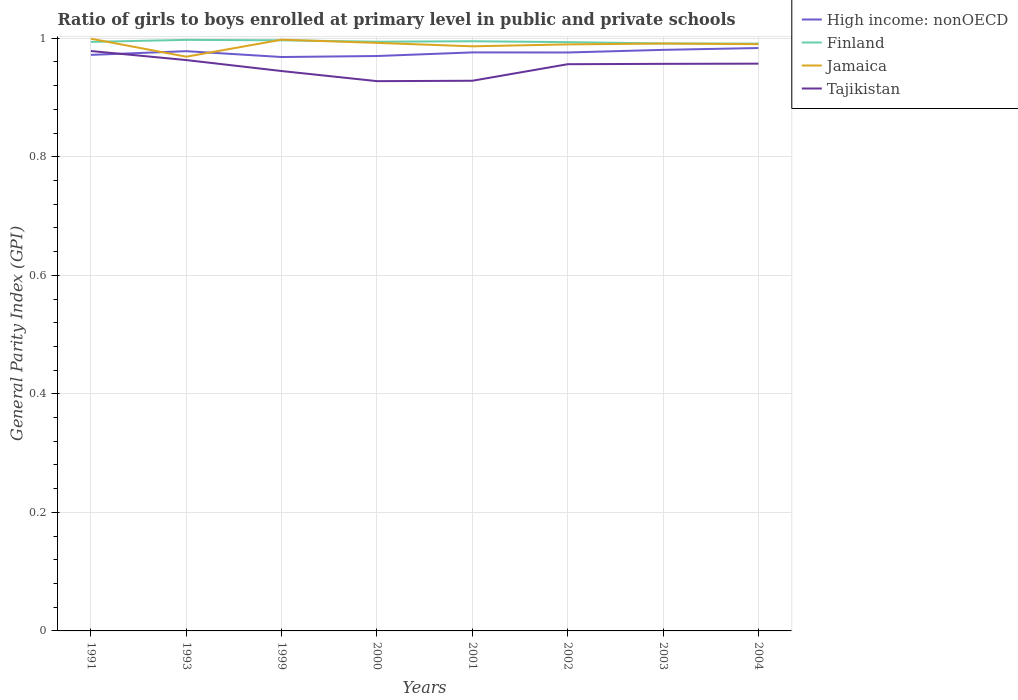Is the number of lines equal to the number of legend labels?
Provide a succinct answer. Yes. Across all years, what is the maximum general parity index in Finland?
Offer a terse response. 0.99. What is the total general parity index in Jamaica in the graph?
Offer a very short reply. 0.01. What is the difference between the highest and the second highest general parity index in Jamaica?
Your response must be concise. 0.03. How many years are there in the graph?
Offer a terse response. 8. What is the difference between two consecutive major ticks on the Y-axis?
Offer a very short reply. 0.2. Where does the legend appear in the graph?
Ensure brevity in your answer.  Top right. How many legend labels are there?
Make the answer very short. 4. What is the title of the graph?
Make the answer very short. Ratio of girls to boys enrolled at primary level in public and private schools. What is the label or title of the Y-axis?
Your answer should be very brief. General Parity Index (GPI). What is the General Parity Index (GPI) in High income: nonOECD in 1991?
Your answer should be very brief. 0.97. What is the General Parity Index (GPI) in Finland in 1991?
Make the answer very short. 0.99. What is the General Parity Index (GPI) in Jamaica in 1991?
Keep it short and to the point. 1. What is the General Parity Index (GPI) in Tajikistan in 1991?
Offer a terse response. 0.98. What is the General Parity Index (GPI) in High income: nonOECD in 1993?
Give a very brief answer. 0.98. What is the General Parity Index (GPI) in Finland in 1993?
Your answer should be compact. 1. What is the General Parity Index (GPI) of Jamaica in 1993?
Your answer should be compact. 0.97. What is the General Parity Index (GPI) in Tajikistan in 1993?
Offer a very short reply. 0.96. What is the General Parity Index (GPI) of High income: nonOECD in 1999?
Your response must be concise. 0.97. What is the General Parity Index (GPI) of Finland in 1999?
Provide a succinct answer. 1. What is the General Parity Index (GPI) in Jamaica in 1999?
Your answer should be very brief. 1. What is the General Parity Index (GPI) of Tajikistan in 1999?
Give a very brief answer. 0.94. What is the General Parity Index (GPI) in High income: nonOECD in 2000?
Ensure brevity in your answer.  0.97. What is the General Parity Index (GPI) of Finland in 2000?
Make the answer very short. 0.99. What is the General Parity Index (GPI) in Jamaica in 2000?
Offer a very short reply. 0.99. What is the General Parity Index (GPI) of Tajikistan in 2000?
Keep it short and to the point. 0.93. What is the General Parity Index (GPI) of High income: nonOECD in 2001?
Offer a very short reply. 0.98. What is the General Parity Index (GPI) in Finland in 2001?
Your answer should be compact. 0.99. What is the General Parity Index (GPI) of Jamaica in 2001?
Offer a terse response. 0.99. What is the General Parity Index (GPI) of Tajikistan in 2001?
Make the answer very short. 0.93. What is the General Parity Index (GPI) in High income: nonOECD in 2002?
Your answer should be very brief. 0.98. What is the General Parity Index (GPI) of Finland in 2002?
Provide a short and direct response. 0.99. What is the General Parity Index (GPI) of Jamaica in 2002?
Ensure brevity in your answer.  0.99. What is the General Parity Index (GPI) of Tajikistan in 2002?
Provide a succinct answer. 0.96. What is the General Parity Index (GPI) of High income: nonOECD in 2003?
Your answer should be compact. 0.98. What is the General Parity Index (GPI) in Finland in 2003?
Your answer should be very brief. 0.99. What is the General Parity Index (GPI) of Jamaica in 2003?
Make the answer very short. 0.99. What is the General Parity Index (GPI) in Tajikistan in 2003?
Offer a very short reply. 0.96. What is the General Parity Index (GPI) of High income: nonOECD in 2004?
Offer a very short reply. 0.98. What is the General Parity Index (GPI) of Finland in 2004?
Make the answer very short. 0.99. What is the General Parity Index (GPI) of Jamaica in 2004?
Give a very brief answer. 0.99. What is the General Parity Index (GPI) of Tajikistan in 2004?
Your response must be concise. 0.96. Across all years, what is the maximum General Parity Index (GPI) of High income: nonOECD?
Ensure brevity in your answer.  0.98. Across all years, what is the maximum General Parity Index (GPI) in Finland?
Offer a terse response. 1. Across all years, what is the maximum General Parity Index (GPI) of Jamaica?
Offer a terse response. 1. Across all years, what is the maximum General Parity Index (GPI) in Tajikistan?
Make the answer very short. 0.98. Across all years, what is the minimum General Parity Index (GPI) of High income: nonOECD?
Offer a very short reply. 0.97. Across all years, what is the minimum General Parity Index (GPI) of Finland?
Provide a succinct answer. 0.99. Across all years, what is the minimum General Parity Index (GPI) of Jamaica?
Give a very brief answer. 0.97. Across all years, what is the minimum General Parity Index (GPI) of Tajikistan?
Provide a succinct answer. 0.93. What is the total General Parity Index (GPI) of High income: nonOECD in the graph?
Provide a short and direct response. 7.8. What is the total General Parity Index (GPI) in Finland in the graph?
Ensure brevity in your answer.  7.95. What is the total General Parity Index (GPI) of Jamaica in the graph?
Ensure brevity in your answer.  7.91. What is the total General Parity Index (GPI) of Tajikistan in the graph?
Your response must be concise. 7.61. What is the difference between the General Parity Index (GPI) in High income: nonOECD in 1991 and that in 1993?
Ensure brevity in your answer.  -0.01. What is the difference between the General Parity Index (GPI) in Finland in 1991 and that in 1993?
Provide a succinct answer. -0. What is the difference between the General Parity Index (GPI) in Jamaica in 1991 and that in 1993?
Provide a succinct answer. 0.03. What is the difference between the General Parity Index (GPI) in Tajikistan in 1991 and that in 1993?
Ensure brevity in your answer.  0.02. What is the difference between the General Parity Index (GPI) in High income: nonOECD in 1991 and that in 1999?
Your answer should be compact. 0. What is the difference between the General Parity Index (GPI) in Finland in 1991 and that in 1999?
Your response must be concise. -0. What is the difference between the General Parity Index (GPI) of Jamaica in 1991 and that in 1999?
Keep it short and to the point. 0. What is the difference between the General Parity Index (GPI) of Tajikistan in 1991 and that in 1999?
Make the answer very short. 0.03. What is the difference between the General Parity Index (GPI) of High income: nonOECD in 1991 and that in 2000?
Make the answer very short. 0. What is the difference between the General Parity Index (GPI) of Finland in 1991 and that in 2000?
Make the answer very short. -0. What is the difference between the General Parity Index (GPI) in Jamaica in 1991 and that in 2000?
Keep it short and to the point. 0.01. What is the difference between the General Parity Index (GPI) of Tajikistan in 1991 and that in 2000?
Make the answer very short. 0.05. What is the difference between the General Parity Index (GPI) of High income: nonOECD in 1991 and that in 2001?
Provide a short and direct response. -0. What is the difference between the General Parity Index (GPI) of Finland in 1991 and that in 2001?
Give a very brief answer. -0. What is the difference between the General Parity Index (GPI) in Jamaica in 1991 and that in 2001?
Give a very brief answer. 0.01. What is the difference between the General Parity Index (GPI) in Tajikistan in 1991 and that in 2001?
Your response must be concise. 0.05. What is the difference between the General Parity Index (GPI) of High income: nonOECD in 1991 and that in 2002?
Ensure brevity in your answer.  -0. What is the difference between the General Parity Index (GPI) of Finland in 1991 and that in 2002?
Keep it short and to the point. 0. What is the difference between the General Parity Index (GPI) of Jamaica in 1991 and that in 2002?
Ensure brevity in your answer.  0.01. What is the difference between the General Parity Index (GPI) in Tajikistan in 1991 and that in 2002?
Your response must be concise. 0.02. What is the difference between the General Parity Index (GPI) in High income: nonOECD in 1991 and that in 2003?
Your response must be concise. -0.01. What is the difference between the General Parity Index (GPI) in Finland in 1991 and that in 2003?
Your response must be concise. 0. What is the difference between the General Parity Index (GPI) of Jamaica in 1991 and that in 2003?
Offer a terse response. 0.01. What is the difference between the General Parity Index (GPI) in Tajikistan in 1991 and that in 2003?
Give a very brief answer. 0.02. What is the difference between the General Parity Index (GPI) in High income: nonOECD in 1991 and that in 2004?
Provide a succinct answer. -0.01. What is the difference between the General Parity Index (GPI) in Finland in 1991 and that in 2004?
Offer a terse response. 0. What is the difference between the General Parity Index (GPI) of Jamaica in 1991 and that in 2004?
Keep it short and to the point. 0.01. What is the difference between the General Parity Index (GPI) of Tajikistan in 1991 and that in 2004?
Your answer should be very brief. 0.02. What is the difference between the General Parity Index (GPI) of High income: nonOECD in 1993 and that in 1999?
Your response must be concise. 0.01. What is the difference between the General Parity Index (GPI) in Finland in 1993 and that in 1999?
Keep it short and to the point. 0. What is the difference between the General Parity Index (GPI) of Jamaica in 1993 and that in 1999?
Give a very brief answer. -0.03. What is the difference between the General Parity Index (GPI) of Tajikistan in 1993 and that in 1999?
Ensure brevity in your answer.  0.02. What is the difference between the General Parity Index (GPI) in High income: nonOECD in 1993 and that in 2000?
Make the answer very short. 0.01. What is the difference between the General Parity Index (GPI) of Finland in 1993 and that in 2000?
Offer a terse response. 0. What is the difference between the General Parity Index (GPI) in Jamaica in 1993 and that in 2000?
Provide a succinct answer. -0.02. What is the difference between the General Parity Index (GPI) in Tajikistan in 1993 and that in 2000?
Your answer should be compact. 0.04. What is the difference between the General Parity Index (GPI) in High income: nonOECD in 1993 and that in 2001?
Provide a short and direct response. 0. What is the difference between the General Parity Index (GPI) of Finland in 1993 and that in 2001?
Make the answer very short. 0. What is the difference between the General Parity Index (GPI) in Jamaica in 1993 and that in 2001?
Your answer should be very brief. -0.02. What is the difference between the General Parity Index (GPI) of Tajikistan in 1993 and that in 2001?
Provide a succinct answer. 0.03. What is the difference between the General Parity Index (GPI) of High income: nonOECD in 1993 and that in 2002?
Your response must be concise. 0. What is the difference between the General Parity Index (GPI) in Finland in 1993 and that in 2002?
Offer a very short reply. 0. What is the difference between the General Parity Index (GPI) in Jamaica in 1993 and that in 2002?
Your answer should be very brief. -0.02. What is the difference between the General Parity Index (GPI) in Tajikistan in 1993 and that in 2002?
Keep it short and to the point. 0.01. What is the difference between the General Parity Index (GPI) of High income: nonOECD in 1993 and that in 2003?
Provide a short and direct response. -0. What is the difference between the General Parity Index (GPI) in Finland in 1993 and that in 2003?
Keep it short and to the point. 0.01. What is the difference between the General Parity Index (GPI) of Jamaica in 1993 and that in 2003?
Your answer should be very brief. -0.02. What is the difference between the General Parity Index (GPI) in Tajikistan in 1993 and that in 2003?
Your answer should be very brief. 0.01. What is the difference between the General Parity Index (GPI) in High income: nonOECD in 1993 and that in 2004?
Give a very brief answer. -0.01. What is the difference between the General Parity Index (GPI) of Finland in 1993 and that in 2004?
Offer a terse response. 0.01. What is the difference between the General Parity Index (GPI) of Jamaica in 1993 and that in 2004?
Make the answer very short. -0.02. What is the difference between the General Parity Index (GPI) in Tajikistan in 1993 and that in 2004?
Give a very brief answer. 0.01. What is the difference between the General Parity Index (GPI) in High income: nonOECD in 1999 and that in 2000?
Give a very brief answer. -0. What is the difference between the General Parity Index (GPI) in Finland in 1999 and that in 2000?
Provide a succinct answer. 0. What is the difference between the General Parity Index (GPI) in Jamaica in 1999 and that in 2000?
Offer a terse response. 0.01. What is the difference between the General Parity Index (GPI) in Tajikistan in 1999 and that in 2000?
Your answer should be very brief. 0.02. What is the difference between the General Parity Index (GPI) of High income: nonOECD in 1999 and that in 2001?
Keep it short and to the point. -0.01. What is the difference between the General Parity Index (GPI) in Finland in 1999 and that in 2001?
Ensure brevity in your answer.  0. What is the difference between the General Parity Index (GPI) of Jamaica in 1999 and that in 2001?
Keep it short and to the point. 0.01. What is the difference between the General Parity Index (GPI) of Tajikistan in 1999 and that in 2001?
Your response must be concise. 0.02. What is the difference between the General Parity Index (GPI) in High income: nonOECD in 1999 and that in 2002?
Provide a short and direct response. -0.01. What is the difference between the General Parity Index (GPI) of Finland in 1999 and that in 2002?
Ensure brevity in your answer.  0. What is the difference between the General Parity Index (GPI) of Jamaica in 1999 and that in 2002?
Your response must be concise. 0.01. What is the difference between the General Parity Index (GPI) in Tajikistan in 1999 and that in 2002?
Offer a very short reply. -0.01. What is the difference between the General Parity Index (GPI) in High income: nonOECD in 1999 and that in 2003?
Your response must be concise. -0.01. What is the difference between the General Parity Index (GPI) of Finland in 1999 and that in 2003?
Provide a short and direct response. 0.01. What is the difference between the General Parity Index (GPI) of Jamaica in 1999 and that in 2003?
Keep it short and to the point. 0.01. What is the difference between the General Parity Index (GPI) of Tajikistan in 1999 and that in 2003?
Ensure brevity in your answer.  -0.01. What is the difference between the General Parity Index (GPI) of High income: nonOECD in 1999 and that in 2004?
Your answer should be compact. -0.02. What is the difference between the General Parity Index (GPI) of Finland in 1999 and that in 2004?
Offer a terse response. 0.01. What is the difference between the General Parity Index (GPI) of Jamaica in 1999 and that in 2004?
Offer a terse response. 0.01. What is the difference between the General Parity Index (GPI) of Tajikistan in 1999 and that in 2004?
Offer a terse response. -0.01. What is the difference between the General Parity Index (GPI) in High income: nonOECD in 2000 and that in 2001?
Give a very brief answer. -0.01. What is the difference between the General Parity Index (GPI) in Finland in 2000 and that in 2001?
Offer a very short reply. -0. What is the difference between the General Parity Index (GPI) of Jamaica in 2000 and that in 2001?
Keep it short and to the point. 0.01. What is the difference between the General Parity Index (GPI) of Tajikistan in 2000 and that in 2001?
Offer a terse response. -0. What is the difference between the General Parity Index (GPI) of High income: nonOECD in 2000 and that in 2002?
Provide a short and direct response. -0.01. What is the difference between the General Parity Index (GPI) of Finland in 2000 and that in 2002?
Offer a terse response. 0. What is the difference between the General Parity Index (GPI) in Jamaica in 2000 and that in 2002?
Your answer should be very brief. 0. What is the difference between the General Parity Index (GPI) of Tajikistan in 2000 and that in 2002?
Ensure brevity in your answer.  -0.03. What is the difference between the General Parity Index (GPI) in High income: nonOECD in 2000 and that in 2003?
Keep it short and to the point. -0.01. What is the difference between the General Parity Index (GPI) of Finland in 2000 and that in 2003?
Make the answer very short. 0. What is the difference between the General Parity Index (GPI) of Jamaica in 2000 and that in 2003?
Provide a succinct answer. 0. What is the difference between the General Parity Index (GPI) of Tajikistan in 2000 and that in 2003?
Keep it short and to the point. -0.03. What is the difference between the General Parity Index (GPI) of High income: nonOECD in 2000 and that in 2004?
Keep it short and to the point. -0.01. What is the difference between the General Parity Index (GPI) in Finland in 2000 and that in 2004?
Your answer should be compact. 0. What is the difference between the General Parity Index (GPI) in Jamaica in 2000 and that in 2004?
Keep it short and to the point. 0. What is the difference between the General Parity Index (GPI) of Tajikistan in 2000 and that in 2004?
Make the answer very short. -0.03. What is the difference between the General Parity Index (GPI) in Finland in 2001 and that in 2002?
Your answer should be very brief. 0. What is the difference between the General Parity Index (GPI) of Jamaica in 2001 and that in 2002?
Offer a very short reply. -0. What is the difference between the General Parity Index (GPI) of Tajikistan in 2001 and that in 2002?
Make the answer very short. -0.03. What is the difference between the General Parity Index (GPI) of High income: nonOECD in 2001 and that in 2003?
Your answer should be very brief. -0. What is the difference between the General Parity Index (GPI) of Finland in 2001 and that in 2003?
Ensure brevity in your answer.  0. What is the difference between the General Parity Index (GPI) of Jamaica in 2001 and that in 2003?
Keep it short and to the point. -0. What is the difference between the General Parity Index (GPI) of Tajikistan in 2001 and that in 2003?
Provide a short and direct response. -0.03. What is the difference between the General Parity Index (GPI) of High income: nonOECD in 2001 and that in 2004?
Your answer should be very brief. -0.01. What is the difference between the General Parity Index (GPI) of Finland in 2001 and that in 2004?
Ensure brevity in your answer.  0. What is the difference between the General Parity Index (GPI) of Jamaica in 2001 and that in 2004?
Your response must be concise. -0. What is the difference between the General Parity Index (GPI) in Tajikistan in 2001 and that in 2004?
Offer a terse response. -0.03. What is the difference between the General Parity Index (GPI) in High income: nonOECD in 2002 and that in 2003?
Provide a short and direct response. -0. What is the difference between the General Parity Index (GPI) of Finland in 2002 and that in 2003?
Offer a terse response. 0. What is the difference between the General Parity Index (GPI) of Jamaica in 2002 and that in 2003?
Your answer should be very brief. -0. What is the difference between the General Parity Index (GPI) in Tajikistan in 2002 and that in 2003?
Make the answer very short. -0. What is the difference between the General Parity Index (GPI) in High income: nonOECD in 2002 and that in 2004?
Your answer should be compact. -0.01. What is the difference between the General Parity Index (GPI) in Finland in 2002 and that in 2004?
Your response must be concise. 0. What is the difference between the General Parity Index (GPI) in Jamaica in 2002 and that in 2004?
Give a very brief answer. -0. What is the difference between the General Parity Index (GPI) of Tajikistan in 2002 and that in 2004?
Offer a terse response. -0. What is the difference between the General Parity Index (GPI) in High income: nonOECD in 2003 and that in 2004?
Keep it short and to the point. -0. What is the difference between the General Parity Index (GPI) in Finland in 2003 and that in 2004?
Provide a succinct answer. 0. What is the difference between the General Parity Index (GPI) in Jamaica in 2003 and that in 2004?
Your answer should be compact. 0. What is the difference between the General Parity Index (GPI) in Tajikistan in 2003 and that in 2004?
Your answer should be compact. -0. What is the difference between the General Parity Index (GPI) of High income: nonOECD in 1991 and the General Parity Index (GPI) of Finland in 1993?
Make the answer very short. -0.03. What is the difference between the General Parity Index (GPI) of High income: nonOECD in 1991 and the General Parity Index (GPI) of Jamaica in 1993?
Your answer should be compact. 0. What is the difference between the General Parity Index (GPI) in High income: nonOECD in 1991 and the General Parity Index (GPI) in Tajikistan in 1993?
Ensure brevity in your answer.  0.01. What is the difference between the General Parity Index (GPI) of Finland in 1991 and the General Parity Index (GPI) of Jamaica in 1993?
Provide a succinct answer. 0.03. What is the difference between the General Parity Index (GPI) in Finland in 1991 and the General Parity Index (GPI) in Tajikistan in 1993?
Your answer should be compact. 0.03. What is the difference between the General Parity Index (GPI) in Jamaica in 1991 and the General Parity Index (GPI) in Tajikistan in 1993?
Offer a very short reply. 0.04. What is the difference between the General Parity Index (GPI) of High income: nonOECD in 1991 and the General Parity Index (GPI) of Finland in 1999?
Your answer should be compact. -0.02. What is the difference between the General Parity Index (GPI) of High income: nonOECD in 1991 and the General Parity Index (GPI) of Jamaica in 1999?
Your answer should be very brief. -0.03. What is the difference between the General Parity Index (GPI) of High income: nonOECD in 1991 and the General Parity Index (GPI) of Tajikistan in 1999?
Offer a very short reply. 0.03. What is the difference between the General Parity Index (GPI) in Finland in 1991 and the General Parity Index (GPI) in Jamaica in 1999?
Your response must be concise. -0. What is the difference between the General Parity Index (GPI) in Finland in 1991 and the General Parity Index (GPI) in Tajikistan in 1999?
Your response must be concise. 0.05. What is the difference between the General Parity Index (GPI) in Jamaica in 1991 and the General Parity Index (GPI) in Tajikistan in 1999?
Provide a succinct answer. 0.05. What is the difference between the General Parity Index (GPI) in High income: nonOECD in 1991 and the General Parity Index (GPI) in Finland in 2000?
Make the answer very short. -0.02. What is the difference between the General Parity Index (GPI) of High income: nonOECD in 1991 and the General Parity Index (GPI) of Jamaica in 2000?
Offer a terse response. -0.02. What is the difference between the General Parity Index (GPI) of High income: nonOECD in 1991 and the General Parity Index (GPI) of Tajikistan in 2000?
Offer a very short reply. 0.04. What is the difference between the General Parity Index (GPI) of Finland in 1991 and the General Parity Index (GPI) of Jamaica in 2000?
Your response must be concise. 0. What is the difference between the General Parity Index (GPI) in Finland in 1991 and the General Parity Index (GPI) in Tajikistan in 2000?
Keep it short and to the point. 0.07. What is the difference between the General Parity Index (GPI) of Jamaica in 1991 and the General Parity Index (GPI) of Tajikistan in 2000?
Give a very brief answer. 0.07. What is the difference between the General Parity Index (GPI) of High income: nonOECD in 1991 and the General Parity Index (GPI) of Finland in 2001?
Offer a terse response. -0.02. What is the difference between the General Parity Index (GPI) in High income: nonOECD in 1991 and the General Parity Index (GPI) in Jamaica in 2001?
Give a very brief answer. -0.01. What is the difference between the General Parity Index (GPI) in High income: nonOECD in 1991 and the General Parity Index (GPI) in Tajikistan in 2001?
Offer a terse response. 0.04. What is the difference between the General Parity Index (GPI) of Finland in 1991 and the General Parity Index (GPI) of Jamaica in 2001?
Provide a short and direct response. 0.01. What is the difference between the General Parity Index (GPI) in Finland in 1991 and the General Parity Index (GPI) in Tajikistan in 2001?
Offer a very short reply. 0.07. What is the difference between the General Parity Index (GPI) in Jamaica in 1991 and the General Parity Index (GPI) in Tajikistan in 2001?
Offer a terse response. 0.07. What is the difference between the General Parity Index (GPI) of High income: nonOECD in 1991 and the General Parity Index (GPI) of Finland in 2002?
Keep it short and to the point. -0.02. What is the difference between the General Parity Index (GPI) of High income: nonOECD in 1991 and the General Parity Index (GPI) of Jamaica in 2002?
Your answer should be very brief. -0.02. What is the difference between the General Parity Index (GPI) of High income: nonOECD in 1991 and the General Parity Index (GPI) of Tajikistan in 2002?
Make the answer very short. 0.02. What is the difference between the General Parity Index (GPI) of Finland in 1991 and the General Parity Index (GPI) of Jamaica in 2002?
Your answer should be compact. 0. What is the difference between the General Parity Index (GPI) in Finland in 1991 and the General Parity Index (GPI) in Tajikistan in 2002?
Provide a short and direct response. 0.04. What is the difference between the General Parity Index (GPI) of Jamaica in 1991 and the General Parity Index (GPI) of Tajikistan in 2002?
Provide a short and direct response. 0.04. What is the difference between the General Parity Index (GPI) of High income: nonOECD in 1991 and the General Parity Index (GPI) of Finland in 2003?
Give a very brief answer. -0.02. What is the difference between the General Parity Index (GPI) of High income: nonOECD in 1991 and the General Parity Index (GPI) of Jamaica in 2003?
Ensure brevity in your answer.  -0.02. What is the difference between the General Parity Index (GPI) of High income: nonOECD in 1991 and the General Parity Index (GPI) of Tajikistan in 2003?
Your answer should be compact. 0.02. What is the difference between the General Parity Index (GPI) of Finland in 1991 and the General Parity Index (GPI) of Jamaica in 2003?
Your answer should be very brief. 0. What is the difference between the General Parity Index (GPI) of Finland in 1991 and the General Parity Index (GPI) of Tajikistan in 2003?
Give a very brief answer. 0.04. What is the difference between the General Parity Index (GPI) in Jamaica in 1991 and the General Parity Index (GPI) in Tajikistan in 2003?
Your answer should be compact. 0.04. What is the difference between the General Parity Index (GPI) in High income: nonOECD in 1991 and the General Parity Index (GPI) in Finland in 2004?
Make the answer very short. -0.02. What is the difference between the General Parity Index (GPI) of High income: nonOECD in 1991 and the General Parity Index (GPI) of Jamaica in 2004?
Keep it short and to the point. -0.02. What is the difference between the General Parity Index (GPI) of High income: nonOECD in 1991 and the General Parity Index (GPI) of Tajikistan in 2004?
Ensure brevity in your answer.  0.01. What is the difference between the General Parity Index (GPI) in Finland in 1991 and the General Parity Index (GPI) in Jamaica in 2004?
Ensure brevity in your answer.  0. What is the difference between the General Parity Index (GPI) of Finland in 1991 and the General Parity Index (GPI) of Tajikistan in 2004?
Make the answer very short. 0.04. What is the difference between the General Parity Index (GPI) of Jamaica in 1991 and the General Parity Index (GPI) of Tajikistan in 2004?
Your answer should be compact. 0.04. What is the difference between the General Parity Index (GPI) of High income: nonOECD in 1993 and the General Parity Index (GPI) of Finland in 1999?
Provide a succinct answer. -0.02. What is the difference between the General Parity Index (GPI) of High income: nonOECD in 1993 and the General Parity Index (GPI) of Jamaica in 1999?
Your answer should be very brief. -0.02. What is the difference between the General Parity Index (GPI) in High income: nonOECD in 1993 and the General Parity Index (GPI) in Tajikistan in 1999?
Provide a short and direct response. 0.03. What is the difference between the General Parity Index (GPI) of Finland in 1993 and the General Parity Index (GPI) of Jamaica in 1999?
Provide a short and direct response. -0. What is the difference between the General Parity Index (GPI) in Finland in 1993 and the General Parity Index (GPI) in Tajikistan in 1999?
Offer a terse response. 0.05. What is the difference between the General Parity Index (GPI) in Jamaica in 1993 and the General Parity Index (GPI) in Tajikistan in 1999?
Provide a short and direct response. 0.02. What is the difference between the General Parity Index (GPI) in High income: nonOECD in 1993 and the General Parity Index (GPI) in Finland in 2000?
Provide a succinct answer. -0.02. What is the difference between the General Parity Index (GPI) in High income: nonOECD in 1993 and the General Parity Index (GPI) in Jamaica in 2000?
Provide a short and direct response. -0.01. What is the difference between the General Parity Index (GPI) of High income: nonOECD in 1993 and the General Parity Index (GPI) of Tajikistan in 2000?
Your answer should be compact. 0.05. What is the difference between the General Parity Index (GPI) of Finland in 1993 and the General Parity Index (GPI) of Jamaica in 2000?
Provide a short and direct response. 0.01. What is the difference between the General Parity Index (GPI) of Finland in 1993 and the General Parity Index (GPI) of Tajikistan in 2000?
Give a very brief answer. 0.07. What is the difference between the General Parity Index (GPI) of Jamaica in 1993 and the General Parity Index (GPI) of Tajikistan in 2000?
Offer a terse response. 0.04. What is the difference between the General Parity Index (GPI) of High income: nonOECD in 1993 and the General Parity Index (GPI) of Finland in 2001?
Provide a short and direct response. -0.02. What is the difference between the General Parity Index (GPI) in High income: nonOECD in 1993 and the General Parity Index (GPI) in Jamaica in 2001?
Offer a terse response. -0.01. What is the difference between the General Parity Index (GPI) in High income: nonOECD in 1993 and the General Parity Index (GPI) in Tajikistan in 2001?
Offer a terse response. 0.05. What is the difference between the General Parity Index (GPI) in Finland in 1993 and the General Parity Index (GPI) in Jamaica in 2001?
Keep it short and to the point. 0.01. What is the difference between the General Parity Index (GPI) of Finland in 1993 and the General Parity Index (GPI) of Tajikistan in 2001?
Provide a short and direct response. 0.07. What is the difference between the General Parity Index (GPI) in Jamaica in 1993 and the General Parity Index (GPI) in Tajikistan in 2001?
Provide a succinct answer. 0.04. What is the difference between the General Parity Index (GPI) in High income: nonOECD in 1993 and the General Parity Index (GPI) in Finland in 2002?
Make the answer very short. -0.02. What is the difference between the General Parity Index (GPI) in High income: nonOECD in 1993 and the General Parity Index (GPI) in Jamaica in 2002?
Keep it short and to the point. -0.01. What is the difference between the General Parity Index (GPI) of High income: nonOECD in 1993 and the General Parity Index (GPI) of Tajikistan in 2002?
Offer a very short reply. 0.02. What is the difference between the General Parity Index (GPI) of Finland in 1993 and the General Parity Index (GPI) of Jamaica in 2002?
Make the answer very short. 0.01. What is the difference between the General Parity Index (GPI) in Finland in 1993 and the General Parity Index (GPI) in Tajikistan in 2002?
Give a very brief answer. 0.04. What is the difference between the General Parity Index (GPI) in Jamaica in 1993 and the General Parity Index (GPI) in Tajikistan in 2002?
Your response must be concise. 0.01. What is the difference between the General Parity Index (GPI) of High income: nonOECD in 1993 and the General Parity Index (GPI) of Finland in 2003?
Ensure brevity in your answer.  -0.01. What is the difference between the General Parity Index (GPI) of High income: nonOECD in 1993 and the General Parity Index (GPI) of Jamaica in 2003?
Make the answer very short. -0.01. What is the difference between the General Parity Index (GPI) in High income: nonOECD in 1993 and the General Parity Index (GPI) in Tajikistan in 2003?
Ensure brevity in your answer.  0.02. What is the difference between the General Parity Index (GPI) in Finland in 1993 and the General Parity Index (GPI) in Jamaica in 2003?
Your response must be concise. 0.01. What is the difference between the General Parity Index (GPI) in Finland in 1993 and the General Parity Index (GPI) in Tajikistan in 2003?
Your answer should be very brief. 0.04. What is the difference between the General Parity Index (GPI) of Jamaica in 1993 and the General Parity Index (GPI) of Tajikistan in 2003?
Provide a succinct answer. 0.01. What is the difference between the General Parity Index (GPI) of High income: nonOECD in 1993 and the General Parity Index (GPI) of Finland in 2004?
Your answer should be compact. -0.01. What is the difference between the General Parity Index (GPI) of High income: nonOECD in 1993 and the General Parity Index (GPI) of Jamaica in 2004?
Give a very brief answer. -0.01. What is the difference between the General Parity Index (GPI) in High income: nonOECD in 1993 and the General Parity Index (GPI) in Tajikistan in 2004?
Make the answer very short. 0.02. What is the difference between the General Parity Index (GPI) in Finland in 1993 and the General Parity Index (GPI) in Jamaica in 2004?
Your answer should be very brief. 0.01. What is the difference between the General Parity Index (GPI) in Finland in 1993 and the General Parity Index (GPI) in Tajikistan in 2004?
Your answer should be compact. 0.04. What is the difference between the General Parity Index (GPI) of Jamaica in 1993 and the General Parity Index (GPI) of Tajikistan in 2004?
Offer a very short reply. 0.01. What is the difference between the General Parity Index (GPI) of High income: nonOECD in 1999 and the General Parity Index (GPI) of Finland in 2000?
Ensure brevity in your answer.  -0.03. What is the difference between the General Parity Index (GPI) of High income: nonOECD in 1999 and the General Parity Index (GPI) of Jamaica in 2000?
Your response must be concise. -0.02. What is the difference between the General Parity Index (GPI) of High income: nonOECD in 1999 and the General Parity Index (GPI) of Tajikistan in 2000?
Your response must be concise. 0.04. What is the difference between the General Parity Index (GPI) of Finland in 1999 and the General Parity Index (GPI) of Jamaica in 2000?
Keep it short and to the point. 0. What is the difference between the General Parity Index (GPI) of Finland in 1999 and the General Parity Index (GPI) of Tajikistan in 2000?
Keep it short and to the point. 0.07. What is the difference between the General Parity Index (GPI) in Jamaica in 1999 and the General Parity Index (GPI) in Tajikistan in 2000?
Your response must be concise. 0.07. What is the difference between the General Parity Index (GPI) in High income: nonOECD in 1999 and the General Parity Index (GPI) in Finland in 2001?
Offer a very short reply. -0.03. What is the difference between the General Parity Index (GPI) of High income: nonOECD in 1999 and the General Parity Index (GPI) of Jamaica in 2001?
Your answer should be compact. -0.02. What is the difference between the General Parity Index (GPI) in High income: nonOECD in 1999 and the General Parity Index (GPI) in Tajikistan in 2001?
Offer a very short reply. 0.04. What is the difference between the General Parity Index (GPI) in Finland in 1999 and the General Parity Index (GPI) in Jamaica in 2001?
Your answer should be compact. 0.01. What is the difference between the General Parity Index (GPI) of Finland in 1999 and the General Parity Index (GPI) of Tajikistan in 2001?
Provide a short and direct response. 0.07. What is the difference between the General Parity Index (GPI) of Jamaica in 1999 and the General Parity Index (GPI) of Tajikistan in 2001?
Offer a very short reply. 0.07. What is the difference between the General Parity Index (GPI) of High income: nonOECD in 1999 and the General Parity Index (GPI) of Finland in 2002?
Your response must be concise. -0.03. What is the difference between the General Parity Index (GPI) of High income: nonOECD in 1999 and the General Parity Index (GPI) of Jamaica in 2002?
Keep it short and to the point. -0.02. What is the difference between the General Parity Index (GPI) of High income: nonOECD in 1999 and the General Parity Index (GPI) of Tajikistan in 2002?
Offer a terse response. 0.01. What is the difference between the General Parity Index (GPI) in Finland in 1999 and the General Parity Index (GPI) in Jamaica in 2002?
Give a very brief answer. 0.01. What is the difference between the General Parity Index (GPI) of Finland in 1999 and the General Parity Index (GPI) of Tajikistan in 2002?
Offer a very short reply. 0.04. What is the difference between the General Parity Index (GPI) of Jamaica in 1999 and the General Parity Index (GPI) of Tajikistan in 2002?
Ensure brevity in your answer.  0.04. What is the difference between the General Parity Index (GPI) in High income: nonOECD in 1999 and the General Parity Index (GPI) in Finland in 2003?
Your response must be concise. -0.02. What is the difference between the General Parity Index (GPI) in High income: nonOECD in 1999 and the General Parity Index (GPI) in Jamaica in 2003?
Your answer should be very brief. -0.02. What is the difference between the General Parity Index (GPI) of High income: nonOECD in 1999 and the General Parity Index (GPI) of Tajikistan in 2003?
Ensure brevity in your answer.  0.01. What is the difference between the General Parity Index (GPI) of Finland in 1999 and the General Parity Index (GPI) of Jamaica in 2003?
Give a very brief answer. 0.01. What is the difference between the General Parity Index (GPI) of Finland in 1999 and the General Parity Index (GPI) of Tajikistan in 2003?
Offer a very short reply. 0.04. What is the difference between the General Parity Index (GPI) of Jamaica in 1999 and the General Parity Index (GPI) of Tajikistan in 2003?
Offer a very short reply. 0.04. What is the difference between the General Parity Index (GPI) of High income: nonOECD in 1999 and the General Parity Index (GPI) of Finland in 2004?
Provide a short and direct response. -0.02. What is the difference between the General Parity Index (GPI) of High income: nonOECD in 1999 and the General Parity Index (GPI) of Jamaica in 2004?
Ensure brevity in your answer.  -0.02. What is the difference between the General Parity Index (GPI) of High income: nonOECD in 1999 and the General Parity Index (GPI) of Tajikistan in 2004?
Provide a succinct answer. 0.01. What is the difference between the General Parity Index (GPI) in Finland in 1999 and the General Parity Index (GPI) in Jamaica in 2004?
Ensure brevity in your answer.  0.01. What is the difference between the General Parity Index (GPI) of Finland in 1999 and the General Parity Index (GPI) of Tajikistan in 2004?
Ensure brevity in your answer.  0.04. What is the difference between the General Parity Index (GPI) of Jamaica in 1999 and the General Parity Index (GPI) of Tajikistan in 2004?
Offer a terse response. 0.04. What is the difference between the General Parity Index (GPI) in High income: nonOECD in 2000 and the General Parity Index (GPI) in Finland in 2001?
Provide a succinct answer. -0.02. What is the difference between the General Parity Index (GPI) in High income: nonOECD in 2000 and the General Parity Index (GPI) in Jamaica in 2001?
Ensure brevity in your answer.  -0.02. What is the difference between the General Parity Index (GPI) of High income: nonOECD in 2000 and the General Parity Index (GPI) of Tajikistan in 2001?
Give a very brief answer. 0.04. What is the difference between the General Parity Index (GPI) in Finland in 2000 and the General Parity Index (GPI) in Jamaica in 2001?
Provide a succinct answer. 0.01. What is the difference between the General Parity Index (GPI) in Finland in 2000 and the General Parity Index (GPI) in Tajikistan in 2001?
Your answer should be compact. 0.07. What is the difference between the General Parity Index (GPI) in Jamaica in 2000 and the General Parity Index (GPI) in Tajikistan in 2001?
Make the answer very short. 0.06. What is the difference between the General Parity Index (GPI) in High income: nonOECD in 2000 and the General Parity Index (GPI) in Finland in 2002?
Give a very brief answer. -0.02. What is the difference between the General Parity Index (GPI) of High income: nonOECD in 2000 and the General Parity Index (GPI) of Jamaica in 2002?
Make the answer very short. -0.02. What is the difference between the General Parity Index (GPI) of High income: nonOECD in 2000 and the General Parity Index (GPI) of Tajikistan in 2002?
Your answer should be compact. 0.01. What is the difference between the General Parity Index (GPI) in Finland in 2000 and the General Parity Index (GPI) in Jamaica in 2002?
Provide a succinct answer. 0. What is the difference between the General Parity Index (GPI) of Finland in 2000 and the General Parity Index (GPI) of Tajikistan in 2002?
Keep it short and to the point. 0.04. What is the difference between the General Parity Index (GPI) of Jamaica in 2000 and the General Parity Index (GPI) of Tajikistan in 2002?
Keep it short and to the point. 0.04. What is the difference between the General Parity Index (GPI) of High income: nonOECD in 2000 and the General Parity Index (GPI) of Finland in 2003?
Keep it short and to the point. -0.02. What is the difference between the General Parity Index (GPI) in High income: nonOECD in 2000 and the General Parity Index (GPI) in Jamaica in 2003?
Provide a short and direct response. -0.02. What is the difference between the General Parity Index (GPI) in High income: nonOECD in 2000 and the General Parity Index (GPI) in Tajikistan in 2003?
Your answer should be compact. 0.01. What is the difference between the General Parity Index (GPI) of Finland in 2000 and the General Parity Index (GPI) of Jamaica in 2003?
Ensure brevity in your answer.  0. What is the difference between the General Parity Index (GPI) of Finland in 2000 and the General Parity Index (GPI) of Tajikistan in 2003?
Ensure brevity in your answer.  0.04. What is the difference between the General Parity Index (GPI) in Jamaica in 2000 and the General Parity Index (GPI) in Tajikistan in 2003?
Your answer should be very brief. 0.04. What is the difference between the General Parity Index (GPI) of High income: nonOECD in 2000 and the General Parity Index (GPI) of Finland in 2004?
Your response must be concise. -0.02. What is the difference between the General Parity Index (GPI) in High income: nonOECD in 2000 and the General Parity Index (GPI) in Jamaica in 2004?
Your response must be concise. -0.02. What is the difference between the General Parity Index (GPI) of High income: nonOECD in 2000 and the General Parity Index (GPI) of Tajikistan in 2004?
Make the answer very short. 0.01. What is the difference between the General Parity Index (GPI) of Finland in 2000 and the General Parity Index (GPI) of Jamaica in 2004?
Your answer should be compact. 0. What is the difference between the General Parity Index (GPI) in Finland in 2000 and the General Parity Index (GPI) in Tajikistan in 2004?
Give a very brief answer. 0.04. What is the difference between the General Parity Index (GPI) in Jamaica in 2000 and the General Parity Index (GPI) in Tajikistan in 2004?
Make the answer very short. 0.04. What is the difference between the General Parity Index (GPI) in High income: nonOECD in 2001 and the General Parity Index (GPI) in Finland in 2002?
Your answer should be very brief. -0.02. What is the difference between the General Parity Index (GPI) in High income: nonOECD in 2001 and the General Parity Index (GPI) in Jamaica in 2002?
Ensure brevity in your answer.  -0.01. What is the difference between the General Parity Index (GPI) of High income: nonOECD in 2001 and the General Parity Index (GPI) of Tajikistan in 2002?
Provide a succinct answer. 0.02. What is the difference between the General Parity Index (GPI) of Finland in 2001 and the General Parity Index (GPI) of Jamaica in 2002?
Provide a succinct answer. 0.01. What is the difference between the General Parity Index (GPI) of Finland in 2001 and the General Parity Index (GPI) of Tajikistan in 2002?
Make the answer very short. 0.04. What is the difference between the General Parity Index (GPI) in Jamaica in 2001 and the General Parity Index (GPI) in Tajikistan in 2002?
Make the answer very short. 0.03. What is the difference between the General Parity Index (GPI) in High income: nonOECD in 2001 and the General Parity Index (GPI) in Finland in 2003?
Make the answer very short. -0.02. What is the difference between the General Parity Index (GPI) of High income: nonOECD in 2001 and the General Parity Index (GPI) of Jamaica in 2003?
Offer a terse response. -0.01. What is the difference between the General Parity Index (GPI) of High income: nonOECD in 2001 and the General Parity Index (GPI) of Tajikistan in 2003?
Keep it short and to the point. 0.02. What is the difference between the General Parity Index (GPI) in Finland in 2001 and the General Parity Index (GPI) in Jamaica in 2003?
Your answer should be very brief. 0. What is the difference between the General Parity Index (GPI) in Finland in 2001 and the General Parity Index (GPI) in Tajikistan in 2003?
Make the answer very short. 0.04. What is the difference between the General Parity Index (GPI) of Jamaica in 2001 and the General Parity Index (GPI) of Tajikistan in 2003?
Your response must be concise. 0.03. What is the difference between the General Parity Index (GPI) in High income: nonOECD in 2001 and the General Parity Index (GPI) in Finland in 2004?
Provide a succinct answer. -0.01. What is the difference between the General Parity Index (GPI) of High income: nonOECD in 2001 and the General Parity Index (GPI) of Jamaica in 2004?
Your answer should be compact. -0.01. What is the difference between the General Parity Index (GPI) in High income: nonOECD in 2001 and the General Parity Index (GPI) in Tajikistan in 2004?
Offer a very short reply. 0.02. What is the difference between the General Parity Index (GPI) of Finland in 2001 and the General Parity Index (GPI) of Jamaica in 2004?
Offer a very short reply. 0. What is the difference between the General Parity Index (GPI) in Finland in 2001 and the General Parity Index (GPI) in Tajikistan in 2004?
Ensure brevity in your answer.  0.04. What is the difference between the General Parity Index (GPI) of Jamaica in 2001 and the General Parity Index (GPI) of Tajikistan in 2004?
Offer a terse response. 0.03. What is the difference between the General Parity Index (GPI) of High income: nonOECD in 2002 and the General Parity Index (GPI) of Finland in 2003?
Give a very brief answer. -0.02. What is the difference between the General Parity Index (GPI) of High income: nonOECD in 2002 and the General Parity Index (GPI) of Jamaica in 2003?
Offer a very short reply. -0.02. What is the difference between the General Parity Index (GPI) in High income: nonOECD in 2002 and the General Parity Index (GPI) in Tajikistan in 2003?
Provide a short and direct response. 0.02. What is the difference between the General Parity Index (GPI) of Finland in 2002 and the General Parity Index (GPI) of Jamaica in 2003?
Give a very brief answer. 0. What is the difference between the General Parity Index (GPI) in Finland in 2002 and the General Parity Index (GPI) in Tajikistan in 2003?
Your answer should be compact. 0.04. What is the difference between the General Parity Index (GPI) in Jamaica in 2002 and the General Parity Index (GPI) in Tajikistan in 2003?
Your answer should be compact. 0.03. What is the difference between the General Parity Index (GPI) of High income: nonOECD in 2002 and the General Parity Index (GPI) of Finland in 2004?
Keep it short and to the point. -0.01. What is the difference between the General Parity Index (GPI) in High income: nonOECD in 2002 and the General Parity Index (GPI) in Jamaica in 2004?
Your answer should be very brief. -0.01. What is the difference between the General Parity Index (GPI) in High income: nonOECD in 2002 and the General Parity Index (GPI) in Tajikistan in 2004?
Ensure brevity in your answer.  0.02. What is the difference between the General Parity Index (GPI) of Finland in 2002 and the General Parity Index (GPI) of Jamaica in 2004?
Ensure brevity in your answer.  0. What is the difference between the General Parity Index (GPI) of Finland in 2002 and the General Parity Index (GPI) of Tajikistan in 2004?
Your answer should be very brief. 0.04. What is the difference between the General Parity Index (GPI) in Jamaica in 2002 and the General Parity Index (GPI) in Tajikistan in 2004?
Offer a very short reply. 0.03. What is the difference between the General Parity Index (GPI) of High income: nonOECD in 2003 and the General Parity Index (GPI) of Finland in 2004?
Your response must be concise. -0.01. What is the difference between the General Parity Index (GPI) of High income: nonOECD in 2003 and the General Parity Index (GPI) of Jamaica in 2004?
Offer a very short reply. -0.01. What is the difference between the General Parity Index (GPI) in High income: nonOECD in 2003 and the General Parity Index (GPI) in Tajikistan in 2004?
Provide a short and direct response. 0.02. What is the difference between the General Parity Index (GPI) of Finland in 2003 and the General Parity Index (GPI) of Jamaica in 2004?
Your answer should be compact. 0. What is the difference between the General Parity Index (GPI) in Finland in 2003 and the General Parity Index (GPI) in Tajikistan in 2004?
Offer a terse response. 0.03. What is the difference between the General Parity Index (GPI) of Jamaica in 2003 and the General Parity Index (GPI) of Tajikistan in 2004?
Keep it short and to the point. 0.03. What is the average General Parity Index (GPI) in High income: nonOECD per year?
Your answer should be very brief. 0.98. What is the average General Parity Index (GPI) of Jamaica per year?
Offer a very short reply. 0.99. What is the average General Parity Index (GPI) of Tajikistan per year?
Offer a very short reply. 0.95. In the year 1991, what is the difference between the General Parity Index (GPI) of High income: nonOECD and General Parity Index (GPI) of Finland?
Offer a terse response. -0.02. In the year 1991, what is the difference between the General Parity Index (GPI) of High income: nonOECD and General Parity Index (GPI) of Jamaica?
Your answer should be compact. -0.03. In the year 1991, what is the difference between the General Parity Index (GPI) of High income: nonOECD and General Parity Index (GPI) of Tajikistan?
Your answer should be compact. -0.01. In the year 1991, what is the difference between the General Parity Index (GPI) of Finland and General Parity Index (GPI) of Jamaica?
Your answer should be compact. -0.01. In the year 1991, what is the difference between the General Parity Index (GPI) in Finland and General Parity Index (GPI) in Tajikistan?
Give a very brief answer. 0.02. In the year 1991, what is the difference between the General Parity Index (GPI) in Jamaica and General Parity Index (GPI) in Tajikistan?
Provide a short and direct response. 0.02. In the year 1993, what is the difference between the General Parity Index (GPI) of High income: nonOECD and General Parity Index (GPI) of Finland?
Your response must be concise. -0.02. In the year 1993, what is the difference between the General Parity Index (GPI) in High income: nonOECD and General Parity Index (GPI) in Jamaica?
Provide a short and direct response. 0.01. In the year 1993, what is the difference between the General Parity Index (GPI) of High income: nonOECD and General Parity Index (GPI) of Tajikistan?
Your answer should be compact. 0.01. In the year 1993, what is the difference between the General Parity Index (GPI) of Finland and General Parity Index (GPI) of Jamaica?
Provide a succinct answer. 0.03. In the year 1993, what is the difference between the General Parity Index (GPI) in Finland and General Parity Index (GPI) in Tajikistan?
Your answer should be compact. 0.03. In the year 1993, what is the difference between the General Parity Index (GPI) in Jamaica and General Parity Index (GPI) in Tajikistan?
Your answer should be very brief. 0.01. In the year 1999, what is the difference between the General Parity Index (GPI) in High income: nonOECD and General Parity Index (GPI) in Finland?
Provide a succinct answer. -0.03. In the year 1999, what is the difference between the General Parity Index (GPI) in High income: nonOECD and General Parity Index (GPI) in Jamaica?
Offer a very short reply. -0.03. In the year 1999, what is the difference between the General Parity Index (GPI) in High income: nonOECD and General Parity Index (GPI) in Tajikistan?
Keep it short and to the point. 0.02. In the year 1999, what is the difference between the General Parity Index (GPI) of Finland and General Parity Index (GPI) of Jamaica?
Your answer should be very brief. -0. In the year 1999, what is the difference between the General Parity Index (GPI) of Finland and General Parity Index (GPI) of Tajikistan?
Give a very brief answer. 0.05. In the year 1999, what is the difference between the General Parity Index (GPI) of Jamaica and General Parity Index (GPI) of Tajikistan?
Offer a very short reply. 0.05. In the year 2000, what is the difference between the General Parity Index (GPI) in High income: nonOECD and General Parity Index (GPI) in Finland?
Your response must be concise. -0.02. In the year 2000, what is the difference between the General Parity Index (GPI) in High income: nonOECD and General Parity Index (GPI) in Jamaica?
Provide a succinct answer. -0.02. In the year 2000, what is the difference between the General Parity Index (GPI) in High income: nonOECD and General Parity Index (GPI) in Tajikistan?
Ensure brevity in your answer.  0.04. In the year 2000, what is the difference between the General Parity Index (GPI) in Finland and General Parity Index (GPI) in Jamaica?
Offer a very short reply. 0. In the year 2000, what is the difference between the General Parity Index (GPI) of Finland and General Parity Index (GPI) of Tajikistan?
Provide a short and direct response. 0.07. In the year 2000, what is the difference between the General Parity Index (GPI) of Jamaica and General Parity Index (GPI) of Tajikistan?
Keep it short and to the point. 0.06. In the year 2001, what is the difference between the General Parity Index (GPI) of High income: nonOECD and General Parity Index (GPI) of Finland?
Make the answer very short. -0.02. In the year 2001, what is the difference between the General Parity Index (GPI) of High income: nonOECD and General Parity Index (GPI) of Jamaica?
Your response must be concise. -0.01. In the year 2001, what is the difference between the General Parity Index (GPI) of High income: nonOECD and General Parity Index (GPI) of Tajikistan?
Give a very brief answer. 0.05. In the year 2001, what is the difference between the General Parity Index (GPI) of Finland and General Parity Index (GPI) of Jamaica?
Keep it short and to the point. 0.01. In the year 2001, what is the difference between the General Parity Index (GPI) of Finland and General Parity Index (GPI) of Tajikistan?
Your answer should be very brief. 0.07. In the year 2001, what is the difference between the General Parity Index (GPI) in Jamaica and General Parity Index (GPI) in Tajikistan?
Ensure brevity in your answer.  0.06. In the year 2002, what is the difference between the General Parity Index (GPI) in High income: nonOECD and General Parity Index (GPI) in Finland?
Keep it short and to the point. -0.02. In the year 2002, what is the difference between the General Parity Index (GPI) of High income: nonOECD and General Parity Index (GPI) of Jamaica?
Keep it short and to the point. -0.01. In the year 2002, what is the difference between the General Parity Index (GPI) in High income: nonOECD and General Parity Index (GPI) in Tajikistan?
Give a very brief answer. 0.02. In the year 2002, what is the difference between the General Parity Index (GPI) in Finland and General Parity Index (GPI) in Jamaica?
Offer a very short reply. 0. In the year 2002, what is the difference between the General Parity Index (GPI) of Finland and General Parity Index (GPI) of Tajikistan?
Provide a succinct answer. 0.04. In the year 2002, what is the difference between the General Parity Index (GPI) in Jamaica and General Parity Index (GPI) in Tajikistan?
Ensure brevity in your answer.  0.03. In the year 2003, what is the difference between the General Parity Index (GPI) of High income: nonOECD and General Parity Index (GPI) of Finland?
Your answer should be compact. -0.01. In the year 2003, what is the difference between the General Parity Index (GPI) of High income: nonOECD and General Parity Index (GPI) of Jamaica?
Your response must be concise. -0.01. In the year 2003, what is the difference between the General Parity Index (GPI) in High income: nonOECD and General Parity Index (GPI) in Tajikistan?
Your answer should be very brief. 0.02. In the year 2003, what is the difference between the General Parity Index (GPI) in Finland and General Parity Index (GPI) in Jamaica?
Make the answer very short. 0. In the year 2003, what is the difference between the General Parity Index (GPI) in Finland and General Parity Index (GPI) in Tajikistan?
Give a very brief answer. 0.03. In the year 2003, what is the difference between the General Parity Index (GPI) in Jamaica and General Parity Index (GPI) in Tajikistan?
Keep it short and to the point. 0.03. In the year 2004, what is the difference between the General Parity Index (GPI) of High income: nonOECD and General Parity Index (GPI) of Finland?
Provide a succinct answer. -0.01. In the year 2004, what is the difference between the General Parity Index (GPI) in High income: nonOECD and General Parity Index (GPI) in Jamaica?
Keep it short and to the point. -0.01. In the year 2004, what is the difference between the General Parity Index (GPI) of High income: nonOECD and General Parity Index (GPI) of Tajikistan?
Provide a succinct answer. 0.03. In the year 2004, what is the difference between the General Parity Index (GPI) in Finland and General Parity Index (GPI) in Jamaica?
Your answer should be compact. 0. In the year 2004, what is the difference between the General Parity Index (GPI) in Finland and General Parity Index (GPI) in Tajikistan?
Your answer should be compact. 0.03. In the year 2004, what is the difference between the General Parity Index (GPI) of Jamaica and General Parity Index (GPI) of Tajikistan?
Provide a short and direct response. 0.03. What is the ratio of the General Parity Index (GPI) of High income: nonOECD in 1991 to that in 1993?
Ensure brevity in your answer.  0.99. What is the ratio of the General Parity Index (GPI) of Jamaica in 1991 to that in 1993?
Offer a very short reply. 1.03. What is the ratio of the General Parity Index (GPI) in Tajikistan in 1991 to that in 1993?
Provide a short and direct response. 1.02. What is the ratio of the General Parity Index (GPI) of Jamaica in 1991 to that in 1999?
Your answer should be compact. 1. What is the ratio of the General Parity Index (GPI) in Tajikistan in 1991 to that in 1999?
Make the answer very short. 1.04. What is the ratio of the General Parity Index (GPI) of High income: nonOECD in 1991 to that in 2000?
Provide a succinct answer. 1. What is the ratio of the General Parity Index (GPI) of Finland in 1991 to that in 2000?
Your answer should be compact. 1. What is the ratio of the General Parity Index (GPI) of Jamaica in 1991 to that in 2000?
Offer a very short reply. 1.01. What is the ratio of the General Parity Index (GPI) of Tajikistan in 1991 to that in 2000?
Give a very brief answer. 1.05. What is the ratio of the General Parity Index (GPI) in High income: nonOECD in 1991 to that in 2001?
Ensure brevity in your answer.  1. What is the ratio of the General Parity Index (GPI) of Finland in 1991 to that in 2001?
Your response must be concise. 1. What is the ratio of the General Parity Index (GPI) of Tajikistan in 1991 to that in 2001?
Give a very brief answer. 1.05. What is the ratio of the General Parity Index (GPI) of High income: nonOECD in 1991 to that in 2002?
Offer a terse response. 1. What is the ratio of the General Parity Index (GPI) in Finland in 1991 to that in 2002?
Your answer should be very brief. 1. What is the ratio of the General Parity Index (GPI) of Jamaica in 1991 to that in 2002?
Offer a terse response. 1.01. What is the ratio of the General Parity Index (GPI) of Tajikistan in 1991 to that in 2002?
Ensure brevity in your answer.  1.02. What is the ratio of the General Parity Index (GPI) in Finland in 1991 to that in 2003?
Provide a short and direct response. 1. What is the ratio of the General Parity Index (GPI) of Jamaica in 1991 to that in 2003?
Offer a very short reply. 1.01. What is the ratio of the General Parity Index (GPI) of Tajikistan in 1991 to that in 2003?
Ensure brevity in your answer.  1.02. What is the ratio of the General Parity Index (GPI) in High income: nonOECD in 1991 to that in 2004?
Your answer should be compact. 0.99. What is the ratio of the General Parity Index (GPI) in Finland in 1991 to that in 2004?
Your response must be concise. 1. What is the ratio of the General Parity Index (GPI) of Jamaica in 1991 to that in 2004?
Your response must be concise. 1.01. What is the ratio of the General Parity Index (GPI) in Tajikistan in 1991 to that in 2004?
Make the answer very short. 1.02. What is the ratio of the General Parity Index (GPI) in High income: nonOECD in 1993 to that in 1999?
Your answer should be compact. 1.01. What is the ratio of the General Parity Index (GPI) in Finland in 1993 to that in 1999?
Your answer should be compact. 1. What is the ratio of the General Parity Index (GPI) in Jamaica in 1993 to that in 1999?
Give a very brief answer. 0.97. What is the ratio of the General Parity Index (GPI) of Tajikistan in 1993 to that in 1999?
Provide a short and direct response. 1.02. What is the ratio of the General Parity Index (GPI) in High income: nonOECD in 1993 to that in 2000?
Offer a terse response. 1.01. What is the ratio of the General Parity Index (GPI) in Finland in 1993 to that in 2000?
Keep it short and to the point. 1. What is the ratio of the General Parity Index (GPI) in Jamaica in 1993 to that in 2000?
Keep it short and to the point. 0.98. What is the ratio of the General Parity Index (GPI) of Tajikistan in 1993 to that in 2000?
Your response must be concise. 1.04. What is the ratio of the General Parity Index (GPI) in High income: nonOECD in 1993 to that in 2001?
Ensure brevity in your answer.  1. What is the ratio of the General Parity Index (GPI) of Finland in 1993 to that in 2001?
Offer a terse response. 1. What is the ratio of the General Parity Index (GPI) of Jamaica in 1993 to that in 2001?
Give a very brief answer. 0.98. What is the ratio of the General Parity Index (GPI) of Tajikistan in 1993 to that in 2001?
Offer a terse response. 1.04. What is the ratio of the General Parity Index (GPI) in Jamaica in 1993 to that in 2002?
Your answer should be very brief. 0.98. What is the ratio of the General Parity Index (GPI) in Tajikistan in 1993 to that in 2002?
Keep it short and to the point. 1.01. What is the ratio of the General Parity Index (GPI) of High income: nonOECD in 1993 to that in 2003?
Your answer should be compact. 1. What is the ratio of the General Parity Index (GPI) of Finland in 1993 to that in 2003?
Provide a succinct answer. 1.01. What is the ratio of the General Parity Index (GPI) in Jamaica in 1993 to that in 2003?
Make the answer very short. 0.98. What is the ratio of the General Parity Index (GPI) of Tajikistan in 1993 to that in 2003?
Your response must be concise. 1.01. What is the ratio of the General Parity Index (GPI) of Jamaica in 1993 to that in 2004?
Your answer should be compact. 0.98. What is the ratio of the General Parity Index (GPI) of Jamaica in 1999 to that in 2000?
Your answer should be very brief. 1.01. What is the ratio of the General Parity Index (GPI) of Tajikistan in 1999 to that in 2000?
Your response must be concise. 1.02. What is the ratio of the General Parity Index (GPI) in High income: nonOECD in 1999 to that in 2001?
Your answer should be compact. 0.99. What is the ratio of the General Parity Index (GPI) of Jamaica in 1999 to that in 2001?
Make the answer very short. 1.01. What is the ratio of the General Parity Index (GPI) of Tajikistan in 1999 to that in 2001?
Provide a succinct answer. 1.02. What is the ratio of the General Parity Index (GPI) in High income: nonOECD in 1999 to that in 2002?
Your answer should be compact. 0.99. What is the ratio of the General Parity Index (GPI) in Jamaica in 1999 to that in 2002?
Ensure brevity in your answer.  1.01. What is the ratio of the General Parity Index (GPI) of Tajikistan in 1999 to that in 2002?
Your answer should be compact. 0.99. What is the ratio of the General Parity Index (GPI) of High income: nonOECD in 1999 to that in 2003?
Make the answer very short. 0.99. What is the ratio of the General Parity Index (GPI) of Finland in 1999 to that in 2003?
Keep it short and to the point. 1.01. What is the ratio of the General Parity Index (GPI) in Jamaica in 1999 to that in 2003?
Provide a succinct answer. 1.01. What is the ratio of the General Parity Index (GPI) of Tajikistan in 1999 to that in 2003?
Offer a terse response. 0.99. What is the ratio of the General Parity Index (GPI) of High income: nonOECD in 1999 to that in 2004?
Your answer should be compact. 0.98. What is the ratio of the General Parity Index (GPI) in Finland in 1999 to that in 2004?
Provide a short and direct response. 1.01. What is the ratio of the General Parity Index (GPI) of Jamaica in 1999 to that in 2004?
Offer a terse response. 1.01. What is the ratio of the General Parity Index (GPI) in Tajikistan in 1999 to that in 2004?
Your response must be concise. 0.99. What is the ratio of the General Parity Index (GPI) of High income: nonOECD in 2000 to that in 2001?
Your response must be concise. 0.99. What is the ratio of the General Parity Index (GPI) in Jamaica in 2000 to that in 2001?
Keep it short and to the point. 1.01. What is the ratio of the General Parity Index (GPI) in Tajikistan in 2000 to that in 2001?
Offer a terse response. 1. What is the ratio of the General Parity Index (GPI) of High income: nonOECD in 2000 to that in 2002?
Offer a terse response. 0.99. What is the ratio of the General Parity Index (GPI) in Jamaica in 2000 to that in 2002?
Give a very brief answer. 1. What is the ratio of the General Parity Index (GPI) in Tajikistan in 2000 to that in 2002?
Ensure brevity in your answer.  0.97. What is the ratio of the General Parity Index (GPI) of Finland in 2000 to that in 2003?
Keep it short and to the point. 1. What is the ratio of the General Parity Index (GPI) of Tajikistan in 2000 to that in 2003?
Offer a very short reply. 0.97. What is the ratio of the General Parity Index (GPI) of High income: nonOECD in 2000 to that in 2004?
Make the answer very short. 0.99. What is the ratio of the General Parity Index (GPI) in Finland in 2000 to that in 2004?
Offer a very short reply. 1. What is the ratio of the General Parity Index (GPI) in Tajikistan in 2000 to that in 2004?
Offer a terse response. 0.97. What is the ratio of the General Parity Index (GPI) of Jamaica in 2001 to that in 2002?
Keep it short and to the point. 1. What is the ratio of the General Parity Index (GPI) of Tajikistan in 2001 to that in 2002?
Offer a very short reply. 0.97. What is the ratio of the General Parity Index (GPI) of Tajikistan in 2001 to that in 2003?
Your response must be concise. 0.97. What is the ratio of the General Parity Index (GPI) in High income: nonOECD in 2001 to that in 2004?
Your answer should be very brief. 0.99. What is the ratio of the General Parity Index (GPI) of Finland in 2001 to that in 2004?
Your answer should be very brief. 1. What is the ratio of the General Parity Index (GPI) of Jamaica in 2001 to that in 2004?
Your answer should be very brief. 1. What is the ratio of the General Parity Index (GPI) of Tajikistan in 2001 to that in 2004?
Offer a very short reply. 0.97. What is the ratio of the General Parity Index (GPI) of Tajikistan in 2002 to that in 2003?
Your response must be concise. 1. What is the ratio of the General Parity Index (GPI) of Finland in 2002 to that in 2004?
Offer a very short reply. 1. What is the ratio of the General Parity Index (GPI) in Jamaica in 2002 to that in 2004?
Your answer should be compact. 1. What is the ratio of the General Parity Index (GPI) in Tajikistan in 2002 to that in 2004?
Make the answer very short. 1. What is the ratio of the General Parity Index (GPI) of High income: nonOECD in 2003 to that in 2004?
Your response must be concise. 1. What is the ratio of the General Parity Index (GPI) of Tajikistan in 2003 to that in 2004?
Provide a short and direct response. 1. What is the difference between the highest and the second highest General Parity Index (GPI) in High income: nonOECD?
Offer a very short reply. 0. What is the difference between the highest and the second highest General Parity Index (GPI) in Finland?
Your response must be concise. 0. What is the difference between the highest and the second highest General Parity Index (GPI) of Jamaica?
Ensure brevity in your answer.  0. What is the difference between the highest and the second highest General Parity Index (GPI) of Tajikistan?
Your answer should be compact. 0.02. What is the difference between the highest and the lowest General Parity Index (GPI) in High income: nonOECD?
Your answer should be very brief. 0.02. What is the difference between the highest and the lowest General Parity Index (GPI) of Finland?
Your answer should be compact. 0.01. What is the difference between the highest and the lowest General Parity Index (GPI) in Jamaica?
Your response must be concise. 0.03. What is the difference between the highest and the lowest General Parity Index (GPI) in Tajikistan?
Give a very brief answer. 0.05. 